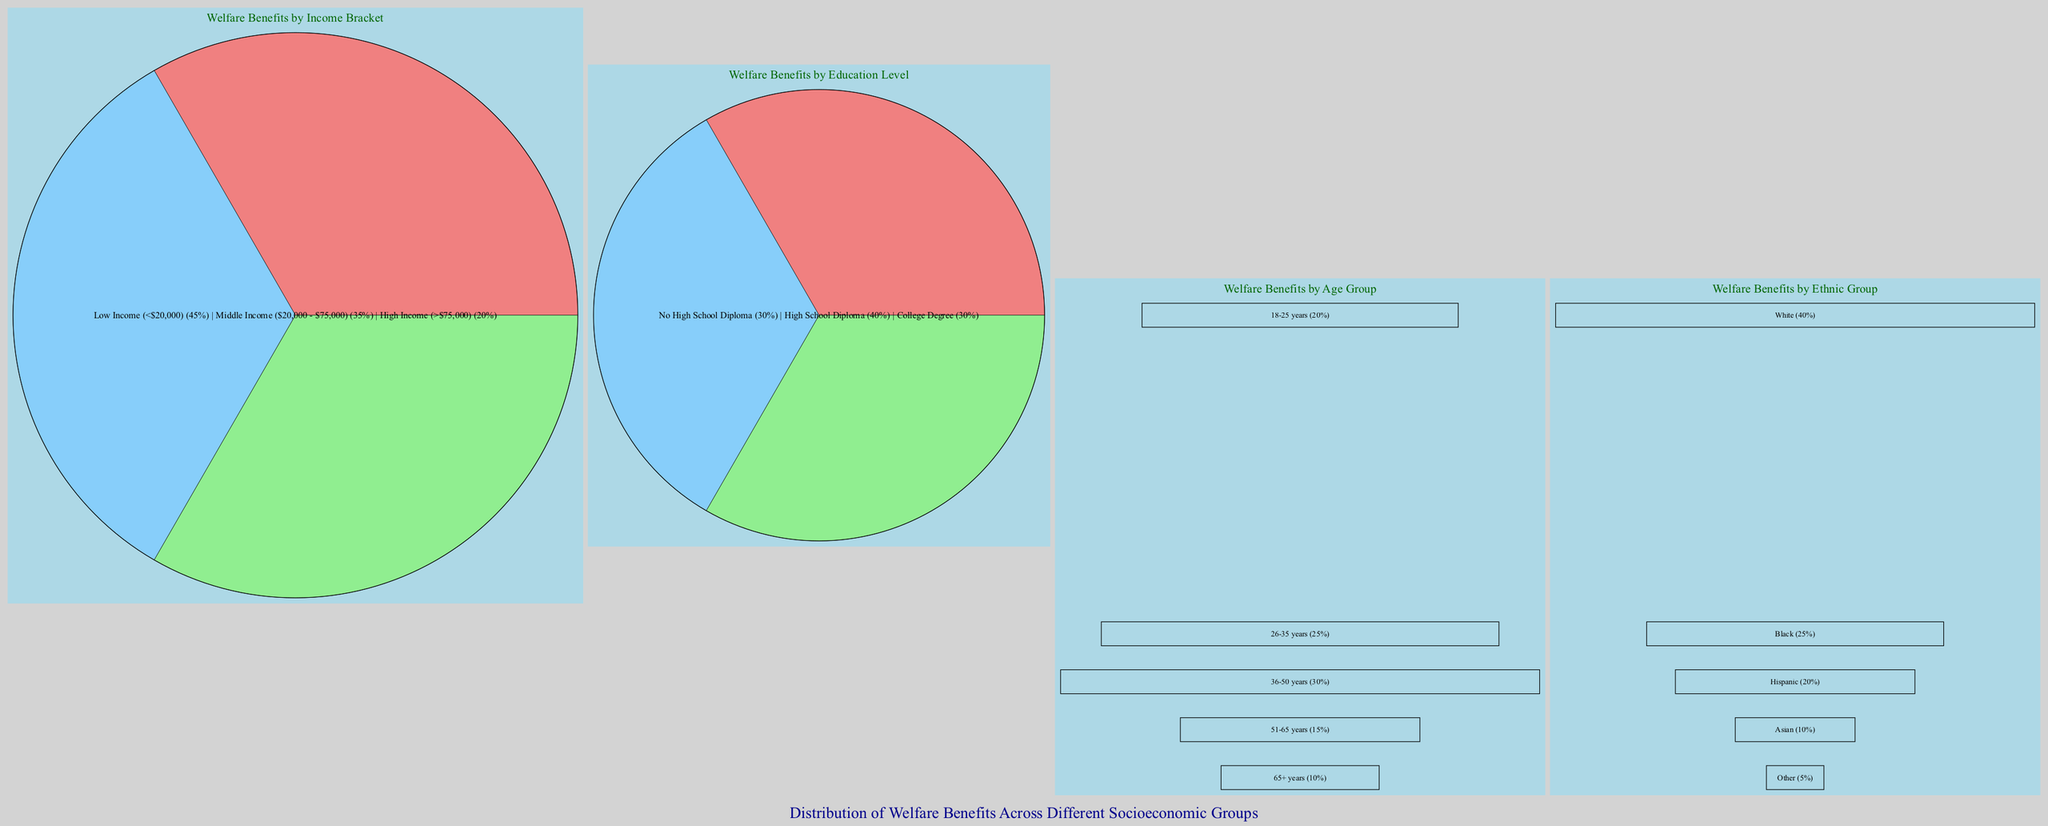What percentage of welfare benefits goes to low-income individuals? According to the pie chart titled “Welfare Benefits by Income Bracket,” low-income individuals, defined as those earning less than $20,000, receive 45% of welfare benefits.
Answer: 45% Which education level receives the highest percentage of welfare benefits? From the pie chart titled “Welfare Benefits by Education Level,” it is evident that individuals with a High School Diploma receive the highest portion of benefits, accounting for 40%.
Answer: High School Diploma What is the percentage distribution of welfare benefits for individuals aged 51-65 years? The bar graph titled “Welfare Benefits by Age Group” shows that individuals aged 51-65 years receive 15% of welfare benefits.
Answer: 15% Which ethnic group receives the least amount of welfare benefits according to the diagram? The bar graph titled “Welfare Benefits by Ethnic Group” indicates that the "Other" category, which encompasses all non-identified ethnic groups, receives the least welfare benefits, at just 5%.
Answer: Other What is the total percentage of welfare benefits distributed among the middle and high-income brackets? By referring to the pie chart “Welfare Benefits by Income Bracket,” middle income (35%) and high income (20%) combined account for 55% of welfare benefits. Thus, adding these two values gives a total of 55%.
Answer: 55% How many age groups are represented in the welfare benefits data? The bar graph titled “Welfare Benefits by Age Group” displays a total of five age groups: 18-25 years, 26-35 years, 36-50 years, 51-65 years, and 65+ years, indicating that there are five distinct groups.
Answer: 5 Which age group shows the highest percentage of welfare benefits and what is that percentage? The bar graph titled “Welfare Benefits by Age Group” illustrates that the age group 36-50 years receives the highest percentage of welfare benefits, which is 30%.
Answer: 30% What is the total percentage of welfare benefits allocated to individuals without a high school diploma and those with a college degree? The pie chart “Welfare Benefits by Education Level” shows that individuals with no high school diploma receive 30%, while those with a college degree also receive 30%. Summing these values results in a total of 60%.
Answer: 60% 